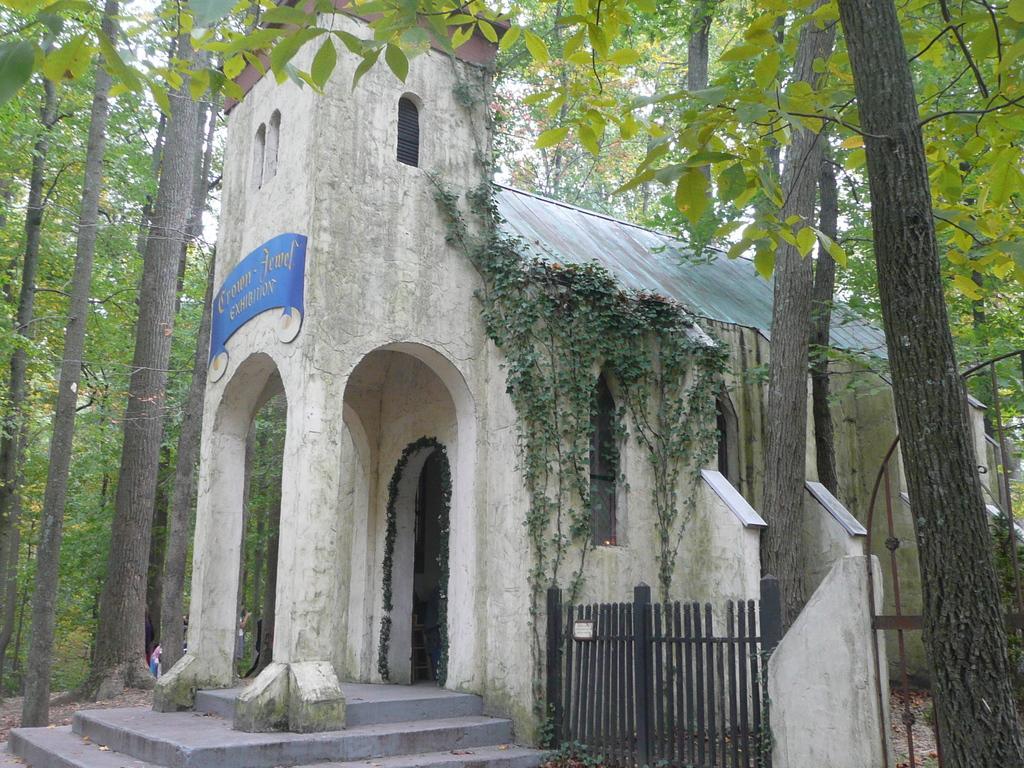In one or two sentences, can you explain what this image depicts? This is a building, these are green color trees. 